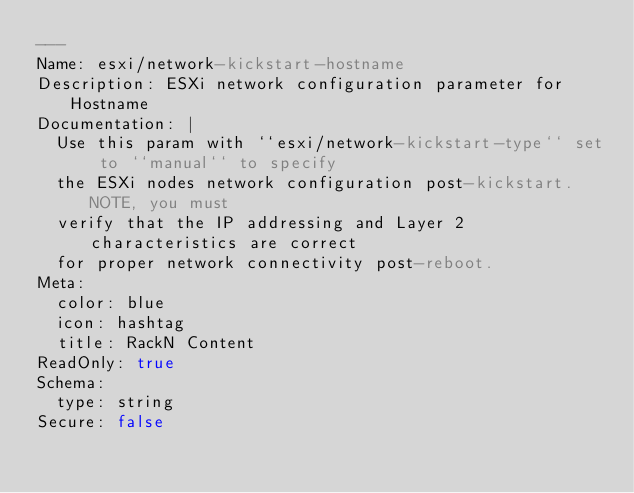<code> <loc_0><loc_0><loc_500><loc_500><_YAML_>---
Name: esxi/network-kickstart-hostname
Description: ESXi network configuration parameter for Hostname
Documentation: |
  Use this param with ``esxi/network-kickstart-type`` set to ``manual`` to specify
  the ESXi nodes network configuration post-kickstart.  NOTE, you must
  verify that the IP addressing and Layer 2 characteristics are correct
  for proper network connectivity post-reboot.
Meta:
  color: blue
  icon: hashtag
  title: RackN Content
ReadOnly: true
Schema:
  type: string
Secure: false
</code> 